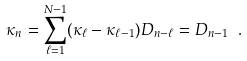Convert formula to latex. <formula><loc_0><loc_0><loc_500><loc_500>\kappa _ { n } = \sum _ { \ell = 1 } ^ { N - 1 } ( \kappa _ { \ell } - \kappa _ { \ell - 1 } ) D _ { n - \ell } = D _ { n - 1 } \ .</formula> 